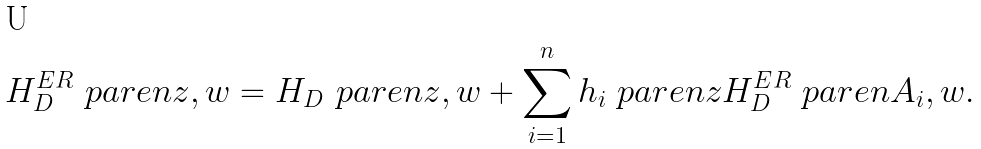Convert formula to latex. <formula><loc_0><loc_0><loc_500><loc_500>H _ { D } ^ { E R } \ p a r e n { z , w } = H _ { D } \ p a r e n { z , w } + \sum _ { i = 1 } ^ { n } h _ { i } \ p a r e n { z } H _ { D } ^ { E R } \ p a r e n { A _ { i } , w } .</formula> 